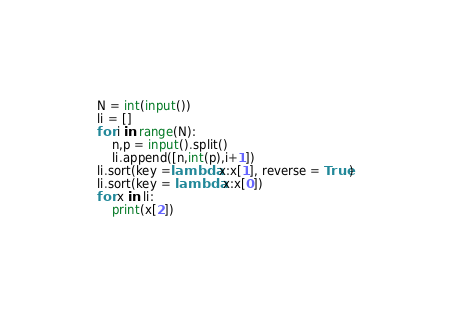<code> <loc_0><loc_0><loc_500><loc_500><_Python_>N = int(input())
li = []
for i in range(N):
    n,p = input().split()
    li.append([n,int(p),i+1])
li.sort(key =lambda x:x[1], reverse = True)
li.sort(key = lambda x:x[0])
for x in li:
    print(x[2])</code> 